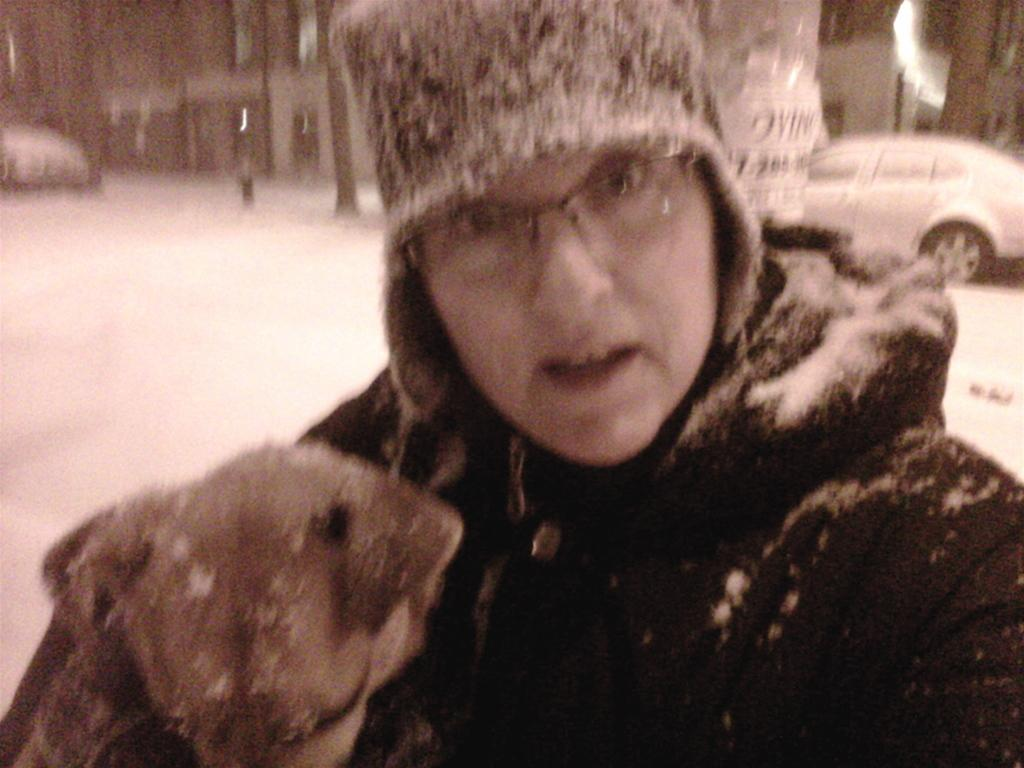Who is present in the image? There is a man in the image. What is the man doing in the image? The man is standing on a path. What can be seen in the background of the image? There are blurred things in the background of the image. What type of pickle is the man holding in the image? There is no pickle present in the image. What is the man using to eat the pickle in the image? There is no pickle or fork present in the image. 